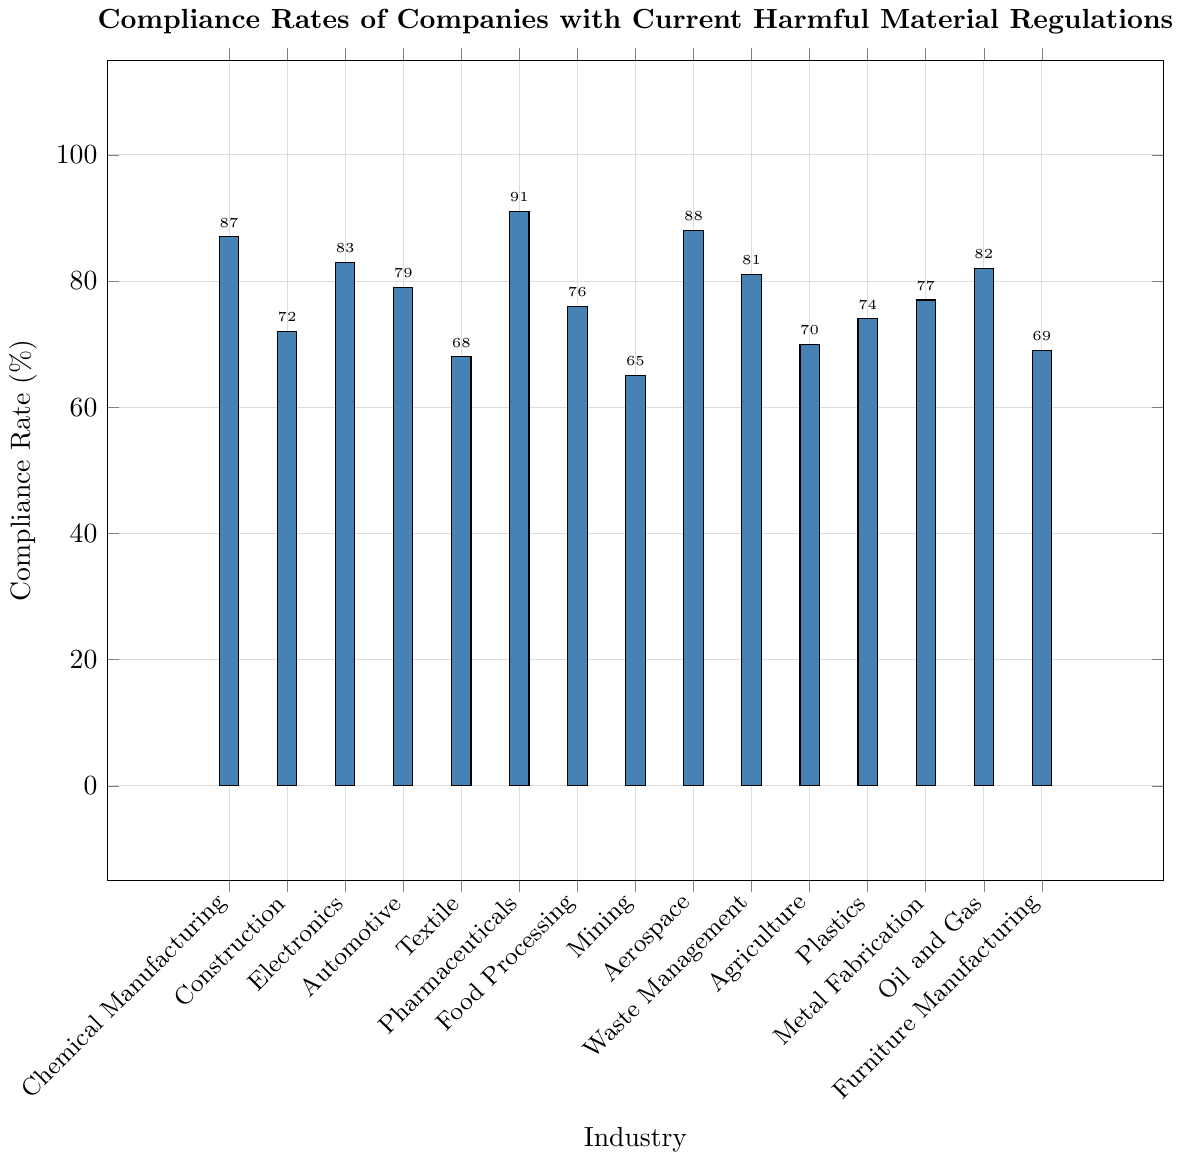Which industry has the highest compliance rate? By looking at the chart, we identify the tallest bar which represents Pharmaceuticals with a compliance rate of 91%.
Answer: Pharmaceuticals What is the difference in compliance rate between Construction and Aerospace? The compliance rate for Construction is 72% and for Aerospace is 88%. The difference is 88% - 72% = 16%.
Answer: 16% Which industries have compliance rates lower than 70%? By examining the bars that do not reach the 70% mark on the y-axis, we find Textile, Mining, Agriculture, and Furniture Manufacturing with compliance rates of 68%, 65%, 70%, and 69% respectively.
Answer: Textile, Mining, Agriculture, Furniture Manufacturing What is the average compliance rate across all industries? To find the average, add all the compliance rates and divide by the number of industries. The sum is 87 + 72 + 83 + 79 + 68 + 91 + 76 + 65 + 88 + 81 + 70 + 74 + 77 + 82 + 69 = 1162. There are 15 industries, so the average is 1162 / 15 ≈ 77.47.
Answer: 77.47 Which industry has a compliance rate closest to the average compliance rate? First, we calculate the average compliance rate as 77.47%. Then, by checking the industries, we find Automotive with a compliance rate of 79%, which is closest to 77.47%.
Answer: Automotive How many industries have a compliance rate above 80%? By counting the bars above the 80% mark on the y-axis, we identify Chemical Manufacturing, Electronics, Pharmaceuticals, Aerospace, Waste Management, and Oil and Gas. There are 6 industries in total.
Answer: 6 What is the compliance rate range among all industries? The range is determined by subtracting the lowest compliance rate from the highest. The lowest rate is for Mining at 65% and the highest is for Pharmaceuticals at 91%. So, the range is 91% - 65% = 26%.
Answer: 26% If the compliance rate of Furniture Manufacturing increased by 10%, what would its new rate be? The current compliance rate of Furniture Manufacturing is 69%. If it increased by 10%, the new rate would be 69% + 10% = 79%.
Answer: 79% Compare the compliance rates between the industries: Waste Management and Food Processing. Which one has a higher rate? Waste Management has a compliance rate of 81% whereas Food Processing has 76%. Therefore, Waste Management has a higher rate.
Answer: Waste Management 